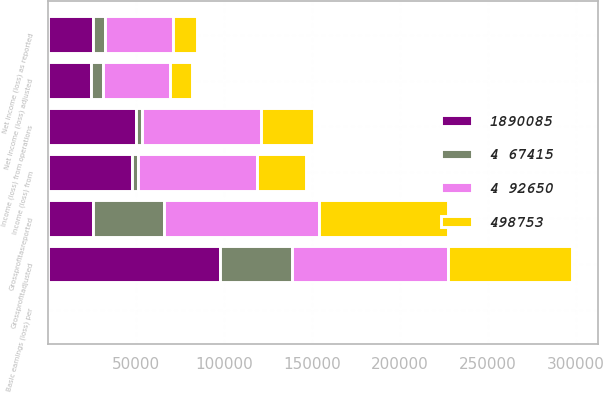<chart> <loc_0><loc_0><loc_500><loc_500><stacked_bar_chart><ecel><fcel>Grossprofitasreported<fcel>Grossprofitadjusted<fcel>Income (loss) from operations<fcel>Income (loss) from<fcel>Net income (loss) as reported<fcel>Net income (loss) adjusted<fcel>Basic earnings (loss) per<nl><fcel>4 67415<fcel>40216<fcel>40629<fcel>3611<fcel>3198<fcel>6836<fcel>6585<fcel>0.06<nl><fcel>498753<fcel>72824<fcel>70700<fcel>30168<fcel>28044<fcel>13626<fcel>12334<fcel>0.12<nl><fcel>1890085<fcel>25673<fcel>97979<fcel>49855<fcel>48103<fcel>25673<fcel>24607<fcel>0.23<nl><fcel>4 92650<fcel>88406<fcel>88406<fcel>67542<fcel>67542<fcel>38374<fcel>38374<fcel>0.36<nl></chart> 